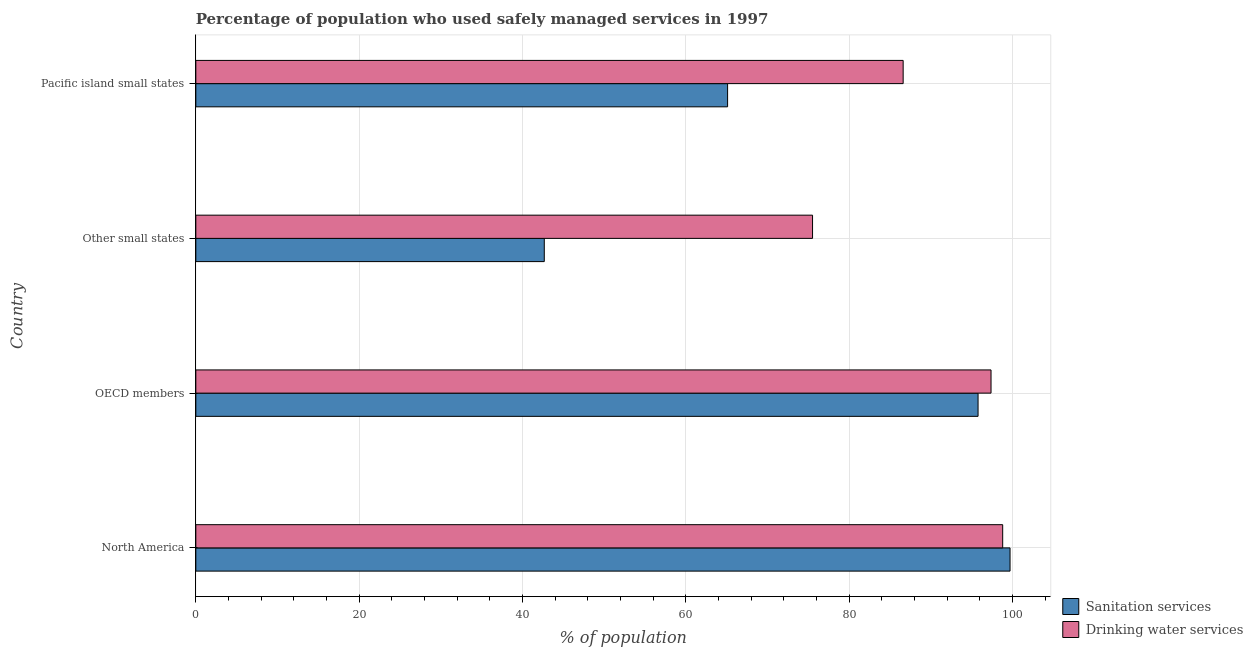Are the number of bars on each tick of the Y-axis equal?
Provide a succinct answer. Yes. How many bars are there on the 2nd tick from the top?
Your answer should be compact. 2. What is the label of the 2nd group of bars from the top?
Your answer should be compact. Other small states. What is the percentage of population who used drinking water services in OECD members?
Your response must be concise. 97.38. Across all countries, what is the maximum percentage of population who used sanitation services?
Give a very brief answer. 99.71. Across all countries, what is the minimum percentage of population who used sanitation services?
Offer a very short reply. 42.67. In which country was the percentage of population who used sanitation services maximum?
Your answer should be compact. North America. In which country was the percentage of population who used sanitation services minimum?
Offer a very short reply. Other small states. What is the total percentage of population who used drinking water services in the graph?
Provide a short and direct response. 358.33. What is the difference between the percentage of population who used drinking water services in Other small states and that in Pacific island small states?
Ensure brevity in your answer.  -11.1. What is the difference between the percentage of population who used sanitation services in OECD members and the percentage of population who used drinking water services in North America?
Your answer should be very brief. -3.02. What is the average percentage of population who used drinking water services per country?
Offer a terse response. 89.58. What is the difference between the percentage of population who used sanitation services and percentage of population who used drinking water services in Pacific island small states?
Your answer should be compact. -21.5. What is the ratio of the percentage of population who used sanitation services in North America to that in OECD members?
Offer a terse response. 1.04. What is the difference between the highest and the second highest percentage of population who used drinking water services?
Give a very brief answer. 1.43. What is the difference between the highest and the lowest percentage of population who used sanitation services?
Offer a very short reply. 57.04. Is the sum of the percentage of population who used drinking water services in OECD members and Other small states greater than the maximum percentage of population who used sanitation services across all countries?
Provide a succinct answer. Yes. What does the 2nd bar from the top in OECD members represents?
Ensure brevity in your answer.  Sanitation services. What does the 1st bar from the bottom in Other small states represents?
Provide a short and direct response. Sanitation services. What is the difference between two consecutive major ticks on the X-axis?
Your response must be concise. 20. Are the values on the major ticks of X-axis written in scientific E-notation?
Provide a short and direct response. No. Does the graph contain grids?
Ensure brevity in your answer.  Yes. How many legend labels are there?
Make the answer very short. 2. What is the title of the graph?
Provide a short and direct response. Percentage of population who used safely managed services in 1997. Does "By country of origin" appear as one of the legend labels in the graph?
Provide a short and direct response. No. What is the label or title of the X-axis?
Ensure brevity in your answer.  % of population. What is the % of population in Sanitation services in North America?
Provide a succinct answer. 99.71. What is the % of population of Drinking water services in North America?
Your response must be concise. 98.81. What is the % of population in Sanitation services in OECD members?
Provide a short and direct response. 95.79. What is the % of population of Drinking water services in OECD members?
Provide a succinct answer. 97.38. What is the % of population in Sanitation services in Other small states?
Provide a succinct answer. 42.67. What is the % of population in Drinking water services in Other small states?
Offer a very short reply. 75.52. What is the % of population in Sanitation services in Pacific island small states?
Keep it short and to the point. 65.12. What is the % of population in Drinking water services in Pacific island small states?
Your response must be concise. 86.62. Across all countries, what is the maximum % of population in Sanitation services?
Provide a short and direct response. 99.71. Across all countries, what is the maximum % of population in Drinking water services?
Give a very brief answer. 98.81. Across all countries, what is the minimum % of population in Sanitation services?
Ensure brevity in your answer.  42.67. Across all countries, what is the minimum % of population in Drinking water services?
Keep it short and to the point. 75.52. What is the total % of population in Sanitation services in the graph?
Your answer should be compact. 303.3. What is the total % of population of Drinking water services in the graph?
Your answer should be very brief. 358.33. What is the difference between the % of population of Sanitation services in North America and that in OECD members?
Offer a very short reply. 3.92. What is the difference between the % of population in Drinking water services in North America and that in OECD members?
Provide a short and direct response. 1.43. What is the difference between the % of population in Sanitation services in North America and that in Other small states?
Your answer should be compact. 57.04. What is the difference between the % of population of Drinking water services in North America and that in Other small states?
Ensure brevity in your answer.  23.28. What is the difference between the % of population of Sanitation services in North America and that in Pacific island small states?
Provide a succinct answer. 34.59. What is the difference between the % of population in Drinking water services in North America and that in Pacific island small states?
Your response must be concise. 12.19. What is the difference between the % of population in Sanitation services in OECD members and that in Other small states?
Provide a succinct answer. 53.12. What is the difference between the % of population in Drinking water services in OECD members and that in Other small states?
Keep it short and to the point. 21.86. What is the difference between the % of population of Sanitation services in OECD members and that in Pacific island small states?
Your response must be concise. 30.67. What is the difference between the % of population of Drinking water services in OECD members and that in Pacific island small states?
Offer a very short reply. 10.76. What is the difference between the % of population in Sanitation services in Other small states and that in Pacific island small states?
Offer a very short reply. -22.45. What is the difference between the % of population in Drinking water services in Other small states and that in Pacific island small states?
Provide a succinct answer. -11.1. What is the difference between the % of population of Sanitation services in North America and the % of population of Drinking water services in OECD members?
Offer a terse response. 2.33. What is the difference between the % of population of Sanitation services in North America and the % of population of Drinking water services in Other small states?
Provide a short and direct response. 24.19. What is the difference between the % of population of Sanitation services in North America and the % of population of Drinking water services in Pacific island small states?
Offer a very short reply. 13.09. What is the difference between the % of population of Sanitation services in OECD members and the % of population of Drinking water services in Other small states?
Provide a short and direct response. 20.27. What is the difference between the % of population in Sanitation services in OECD members and the % of population in Drinking water services in Pacific island small states?
Ensure brevity in your answer.  9.17. What is the difference between the % of population of Sanitation services in Other small states and the % of population of Drinking water services in Pacific island small states?
Make the answer very short. -43.95. What is the average % of population in Sanitation services per country?
Offer a very short reply. 75.82. What is the average % of population in Drinking water services per country?
Give a very brief answer. 89.58. What is the difference between the % of population in Sanitation services and % of population in Drinking water services in North America?
Keep it short and to the point. 0.9. What is the difference between the % of population of Sanitation services and % of population of Drinking water services in OECD members?
Your answer should be very brief. -1.59. What is the difference between the % of population of Sanitation services and % of population of Drinking water services in Other small states?
Provide a short and direct response. -32.85. What is the difference between the % of population of Sanitation services and % of population of Drinking water services in Pacific island small states?
Provide a short and direct response. -21.5. What is the ratio of the % of population of Sanitation services in North America to that in OECD members?
Offer a very short reply. 1.04. What is the ratio of the % of population in Drinking water services in North America to that in OECD members?
Provide a short and direct response. 1.01. What is the ratio of the % of population in Sanitation services in North America to that in Other small states?
Your answer should be very brief. 2.34. What is the ratio of the % of population in Drinking water services in North America to that in Other small states?
Ensure brevity in your answer.  1.31. What is the ratio of the % of population in Sanitation services in North America to that in Pacific island small states?
Give a very brief answer. 1.53. What is the ratio of the % of population of Drinking water services in North America to that in Pacific island small states?
Your response must be concise. 1.14. What is the ratio of the % of population in Sanitation services in OECD members to that in Other small states?
Keep it short and to the point. 2.24. What is the ratio of the % of population of Drinking water services in OECD members to that in Other small states?
Your response must be concise. 1.29. What is the ratio of the % of population of Sanitation services in OECD members to that in Pacific island small states?
Make the answer very short. 1.47. What is the ratio of the % of population of Drinking water services in OECD members to that in Pacific island small states?
Ensure brevity in your answer.  1.12. What is the ratio of the % of population in Sanitation services in Other small states to that in Pacific island small states?
Ensure brevity in your answer.  0.66. What is the ratio of the % of population of Drinking water services in Other small states to that in Pacific island small states?
Offer a very short reply. 0.87. What is the difference between the highest and the second highest % of population in Sanitation services?
Provide a short and direct response. 3.92. What is the difference between the highest and the second highest % of population in Drinking water services?
Your response must be concise. 1.43. What is the difference between the highest and the lowest % of population in Sanitation services?
Offer a very short reply. 57.04. What is the difference between the highest and the lowest % of population of Drinking water services?
Provide a short and direct response. 23.28. 